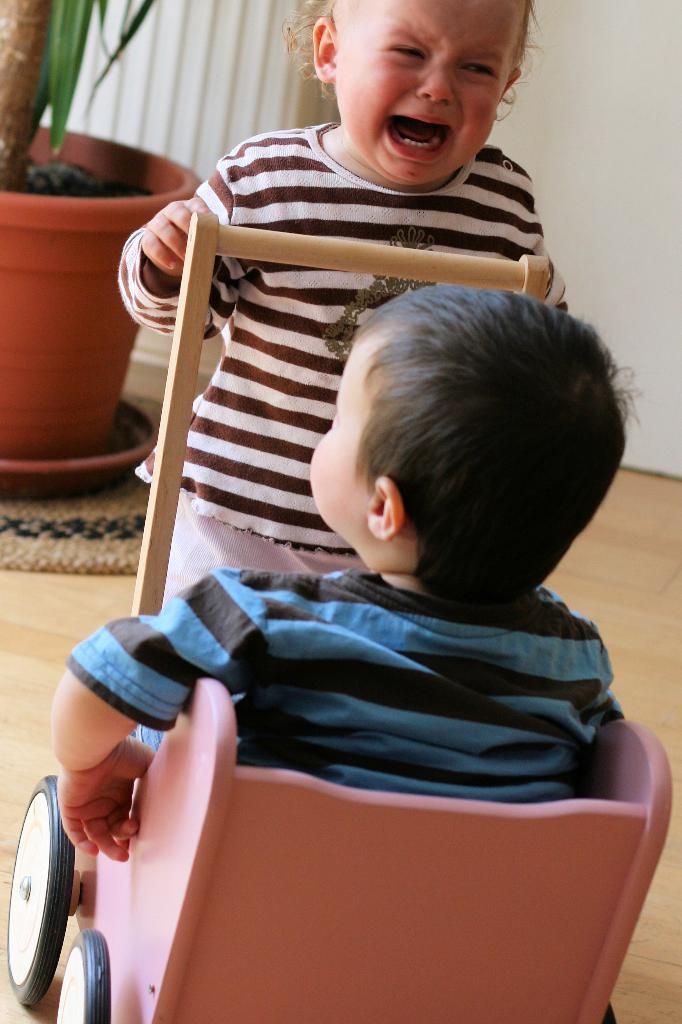What is happening with the baby in the image? There is a baby crying in the image. What is the other baby doing in the image? The other baby is sitting in a toy vehicle in the image. What can be seen in the background of the image? There is a pot, a plant, a carpet, and a wall in the background of the image. What type of wire can be seen hanging from the wall in the image? There is no wire hanging from the wall in the image. Can you describe the alley where the babies are playing in the image? There is no alley present in the image; it takes place indoors with a carpet and a wall in the background. 